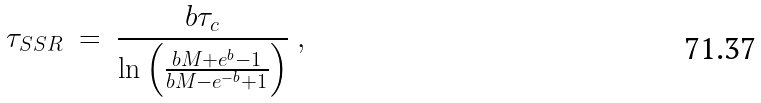<formula> <loc_0><loc_0><loc_500><loc_500>\tau _ { S S R } \ = \ \frac { b \tau _ { c } } { \ln \left ( \frac { b M + e ^ { b } - 1 } { b M - e ^ { - b } + 1 } \right ) } \ ,</formula> 